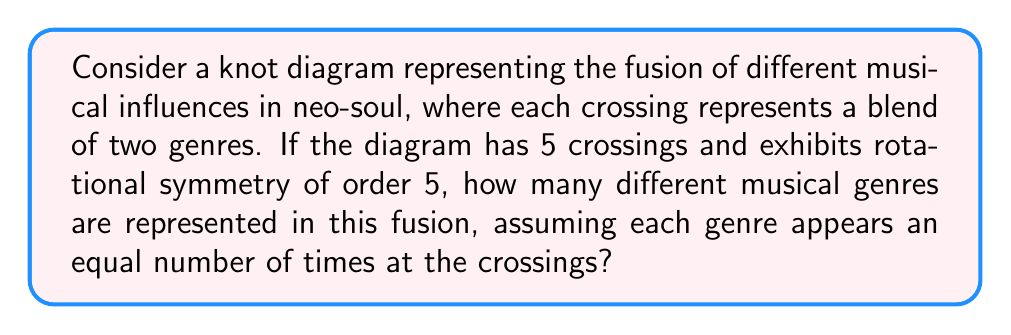Can you answer this question? Let's approach this step-by-step:

1) In knot theory, a knot with rotational symmetry of order 5 means that the knot looks the same after being rotated by $\frac{2\pi}{5}$ radians.

2) Given that there are 5 crossings and the knot has 5-fold rotational symmetry, each crossing must represent a unique position in the rotational symmetry.

3) At each crossing, two genres blend. Let's denote the number of genres as $n$.

4) For the symmetry to hold, each genre must appear the same number of times at the crossings. Let's call this number $k$.

5) Since there are 5 crossings, and each crossing involves 2 genres, the total number of genre appearances is $5 * 2 = 10$.

6) This total must be divisible by the number of genres $n$ for each genre to appear equally:

   $$ 10 = n * k $$

7) The possible factors of 10 are 1, 2, 5, and 10. However, we need at least 2 genres for a fusion, and having 10 different genres would mean each appears only once, which doesn't satisfy our equal appearance condition.

8) Therefore, the only valid solution is $n = 5$ and $k = 2$.

Thus, there are 5 different musical genres represented in this fusion, with each genre appearing twice at the crossings.
Answer: 5 